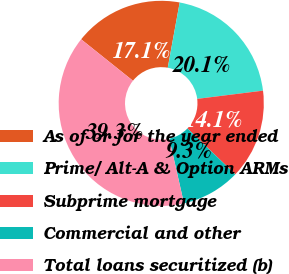Convert chart to OTSL. <chart><loc_0><loc_0><loc_500><loc_500><pie_chart><fcel>As of or for the year ended<fcel>Prime/ Alt-A & Option ARMs<fcel>Subprime mortgage<fcel>Commercial and other<fcel>Total loans securitized (b)<nl><fcel>17.14%<fcel>20.14%<fcel>14.14%<fcel>9.28%<fcel>39.29%<nl></chart> 